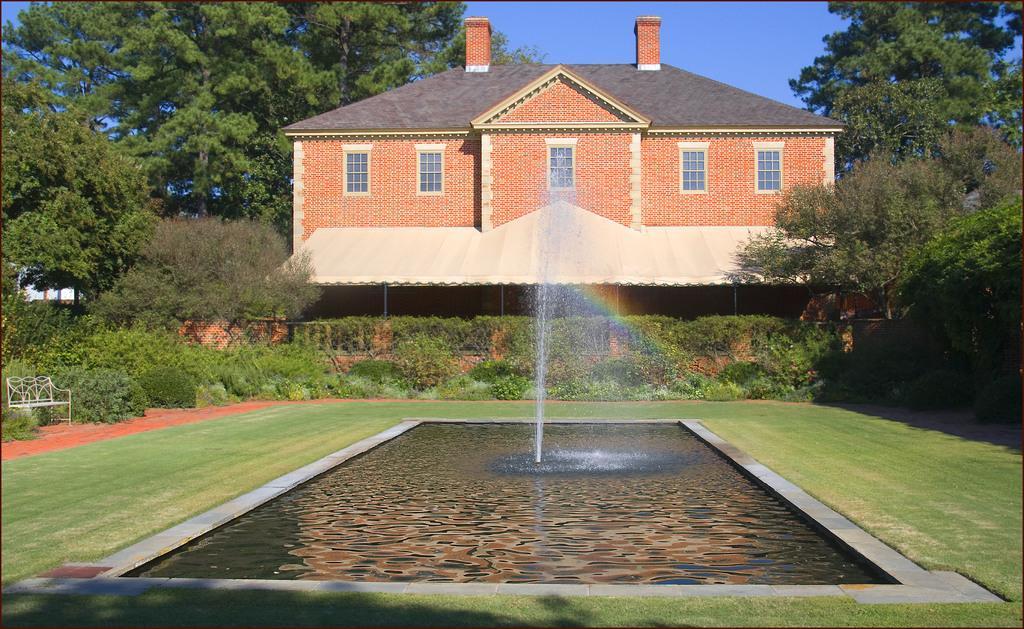Could you give a brief overview of what you see in this image? In the image we can see there is a fountain and there is a water. The ground is covered with grass and behind there are plants and trees. There is a building and there is a clear sky on the top. 